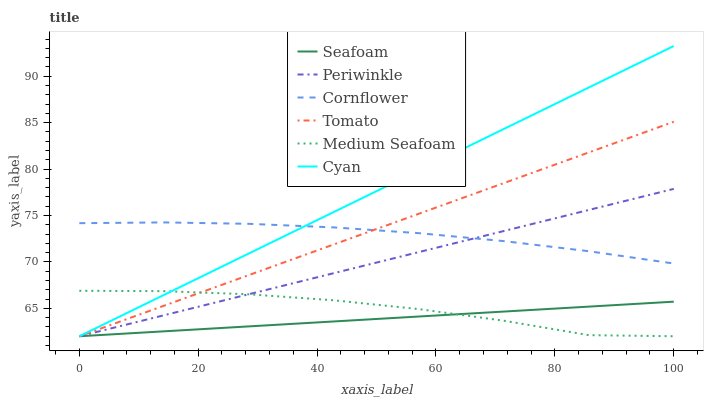Does Cornflower have the minimum area under the curve?
Answer yes or no. No. Does Cornflower have the maximum area under the curve?
Answer yes or no. No. Is Cornflower the smoothest?
Answer yes or no. No. Is Cornflower the roughest?
Answer yes or no. No. Does Cornflower have the lowest value?
Answer yes or no. No. Does Cornflower have the highest value?
Answer yes or no. No. Is Seafoam less than Cornflower?
Answer yes or no. Yes. Is Cornflower greater than Seafoam?
Answer yes or no. Yes. Does Seafoam intersect Cornflower?
Answer yes or no. No. 